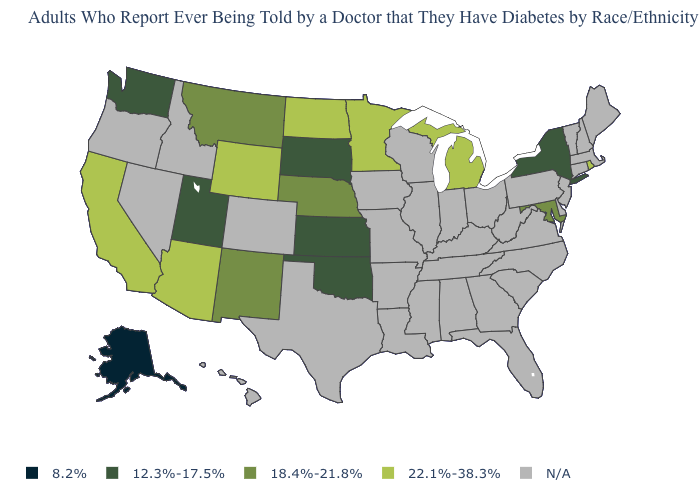Name the states that have a value in the range N/A?
Quick response, please. Alabama, Arkansas, Colorado, Connecticut, Delaware, Florida, Georgia, Hawaii, Idaho, Illinois, Indiana, Iowa, Kentucky, Louisiana, Maine, Massachusetts, Mississippi, Missouri, Nevada, New Hampshire, New Jersey, North Carolina, Ohio, Oregon, Pennsylvania, South Carolina, Tennessee, Texas, Vermont, Virginia, West Virginia, Wisconsin. Among the states that border Vermont , which have the highest value?
Keep it brief. New York. Which states have the lowest value in the USA?
Short answer required. Alaska. Is the legend a continuous bar?
Quick response, please. No. What is the value of Washington?
Keep it brief. 12.3%-17.5%. Is the legend a continuous bar?
Keep it brief. No. Does Alaska have the highest value in the USA?
Give a very brief answer. No. Which states hav the highest value in the South?
Write a very short answer. Maryland. Which states have the highest value in the USA?
Give a very brief answer. Arizona, California, Michigan, Minnesota, North Dakota, Rhode Island, Wyoming. What is the highest value in the USA?
Write a very short answer. 22.1%-38.3%. What is the value of Nebraska?
Quick response, please. 18.4%-21.8%. Does Nebraska have the highest value in the USA?
Give a very brief answer. No. Does the first symbol in the legend represent the smallest category?
Be succinct. Yes. What is the lowest value in the USA?
Answer briefly. 8.2%. Name the states that have a value in the range 8.2%?
Concise answer only. Alaska. 